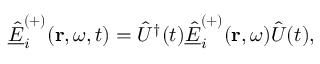<formula> <loc_0><loc_0><loc_500><loc_500>\underline { { \hat { E } } } _ { i } ^ { ( + ) } ( r , \omega , t ) = \hat { U } ^ { \dagger } ( t ) \underline { { \hat { E } } } _ { i } ^ { ( + ) } ( r , \omega ) \hat { U } ( t ) ,</formula> 